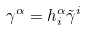<formula> <loc_0><loc_0><loc_500><loc_500>\gamma ^ { \alpha } = h _ { i } ^ { \alpha } \tilde { \gamma } ^ { i }</formula> 